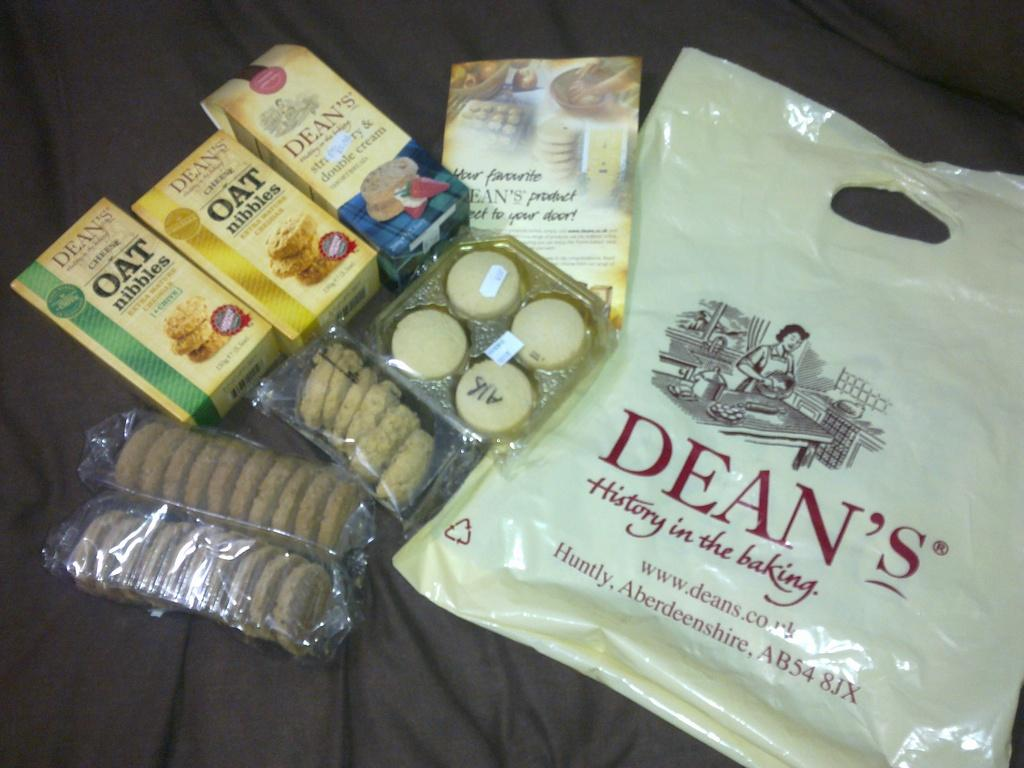What type of food items are present in the image? There are boxes of biscuits and boxes of oats in the image. Where are the boxes located in the image? The boxes are placed on the left side of the image. What other item can be seen in the image? There is a baking cover in the image. Where is the baking cover located in the image? The baking cover is on the right side of the image. What type of tin is being used by the laborer in the image? There is no laborer or tin present in the image. What type of meat is being prepared in the image? There is no meat or preparation of food visible in the image. 